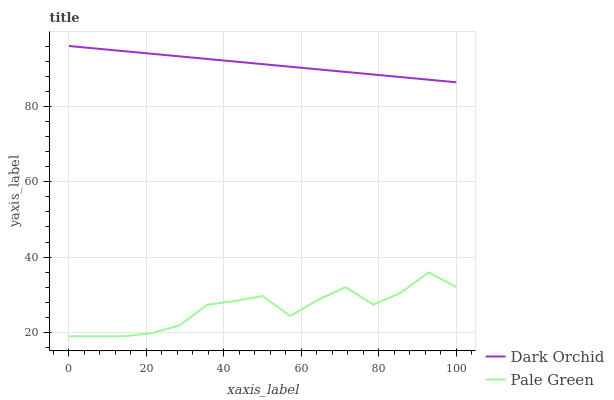Does Pale Green have the minimum area under the curve?
Answer yes or no. Yes. Does Dark Orchid have the maximum area under the curve?
Answer yes or no. Yes. Does Dark Orchid have the minimum area under the curve?
Answer yes or no. No. Is Dark Orchid the smoothest?
Answer yes or no. Yes. Is Pale Green the roughest?
Answer yes or no. Yes. Is Dark Orchid the roughest?
Answer yes or no. No. Does Dark Orchid have the lowest value?
Answer yes or no. No. Does Dark Orchid have the highest value?
Answer yes or no. Yes. Is Pale Green less than Dark Orchid?
Answer yes or no. Yes. Is Dark Orchid greater than Pale Green?
Answer yes or no. Yes. Does Pale Green intersect Dark Orchid?
Answer yes or no. No. 